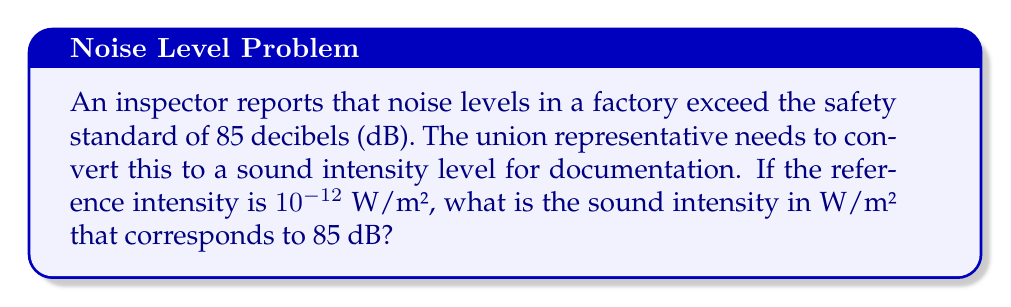Provide a solution to this math problem. To solve this problem, we need to use the relationship between decibels and sound intensity. The formula for sound intensity level (SIL) in decibels is:

$$ SIL = 10 \log_{10} \left(\frac{I}{I_0}\right) $$

Where:
$SIL$ is the sound intensity level in decibels (dB)
$I$ is the sound intensity in W/m²
$I_0$ is the reference intensity, given as $10^{-12}$ W/m²

We are given that $SIL = 85$ dB and need to find $I$. Let's solve the equation:

1) First, we substitute the known values:

   $$ 85 = 10 \log_{10} \left(\frac{I}{10^{-12}}\right) $$

2) Divide both sides by 10:

   $$ 8.5 = \log_{10} \left(\frac{I}{10^{-12}}\right) $$

3) Now, we can apply the inverse operation (10 to the power) on both sides:

   $$ 10^{8.5} = \frac{I}{10^{-12}} $$

4) Simplify the left side:

   $$ 3.16227766 \times 10^8 = \frac{I}{10^{-12}} $$

5) Multiply both sides by $10^{-12}$:

   $$ (3.16227766 \times 10^8) \times 10^{-12} = I $$

6) Simplify:

   $$ 3.16227766 \times 10^{-4} = I $$

Therefore, the sound intensity is approximately $3.16 \times 10^{-4}$ W/m².
Answer: $3.16 \times 10^{-4}$ W/m² 